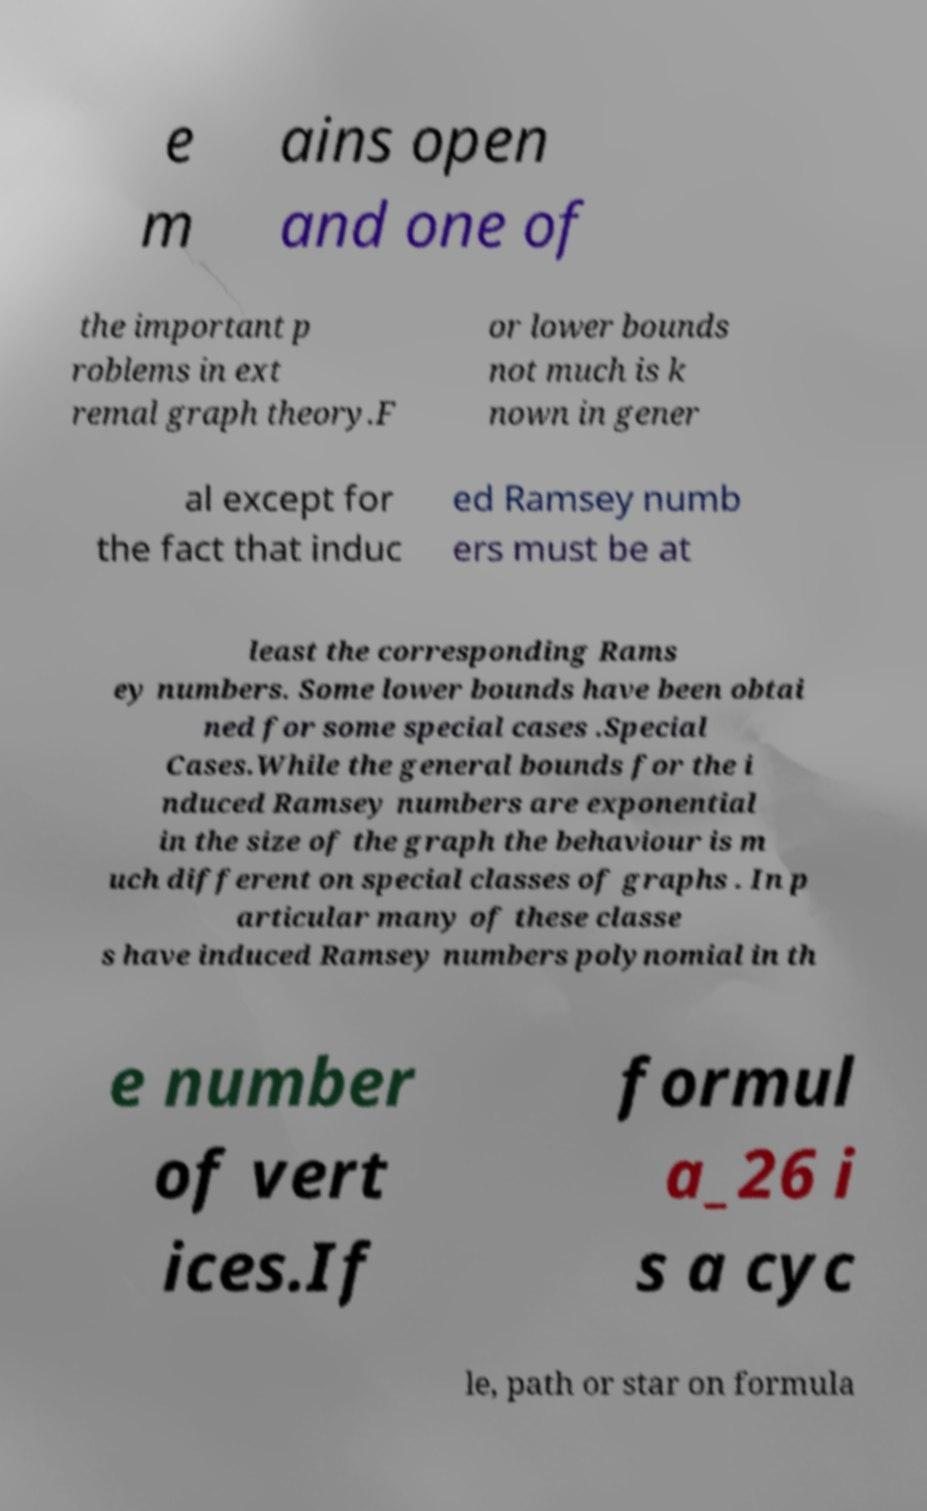What messages or text are displayed in this image? I need them in a readable, typed format. e m ains open and one of the important p roblems in ext remal graph theory.F or lower bounds not much is k nown in gener al except for the fact that induc ed Ramsey numb ers must be at least the corresponding Rams ey numbers. Some lower bounds have been obtai ned for some special cases .Special Cases.While the general bounds for the i nduced Ramsey numbers are exponential in the size of the graph the behaviour is m uch different on special classes of graphs . In p articular many of these classe s have induced Ramsey numbers polynomial in th e number of vert ices.If formul a_26 i s a cyc le, path or star on formula 